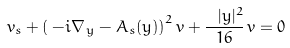<formula> <loc_0><loc_0><loc_500><loc_500>v _ { s } + \left ( \, - i \nabla _ { \, y } - A _ { s } ( y ) \right ) ^ { 2 } v + \frac { \ | y | ^ { 2 } } { 1 6 } \, v = 0</formula> 